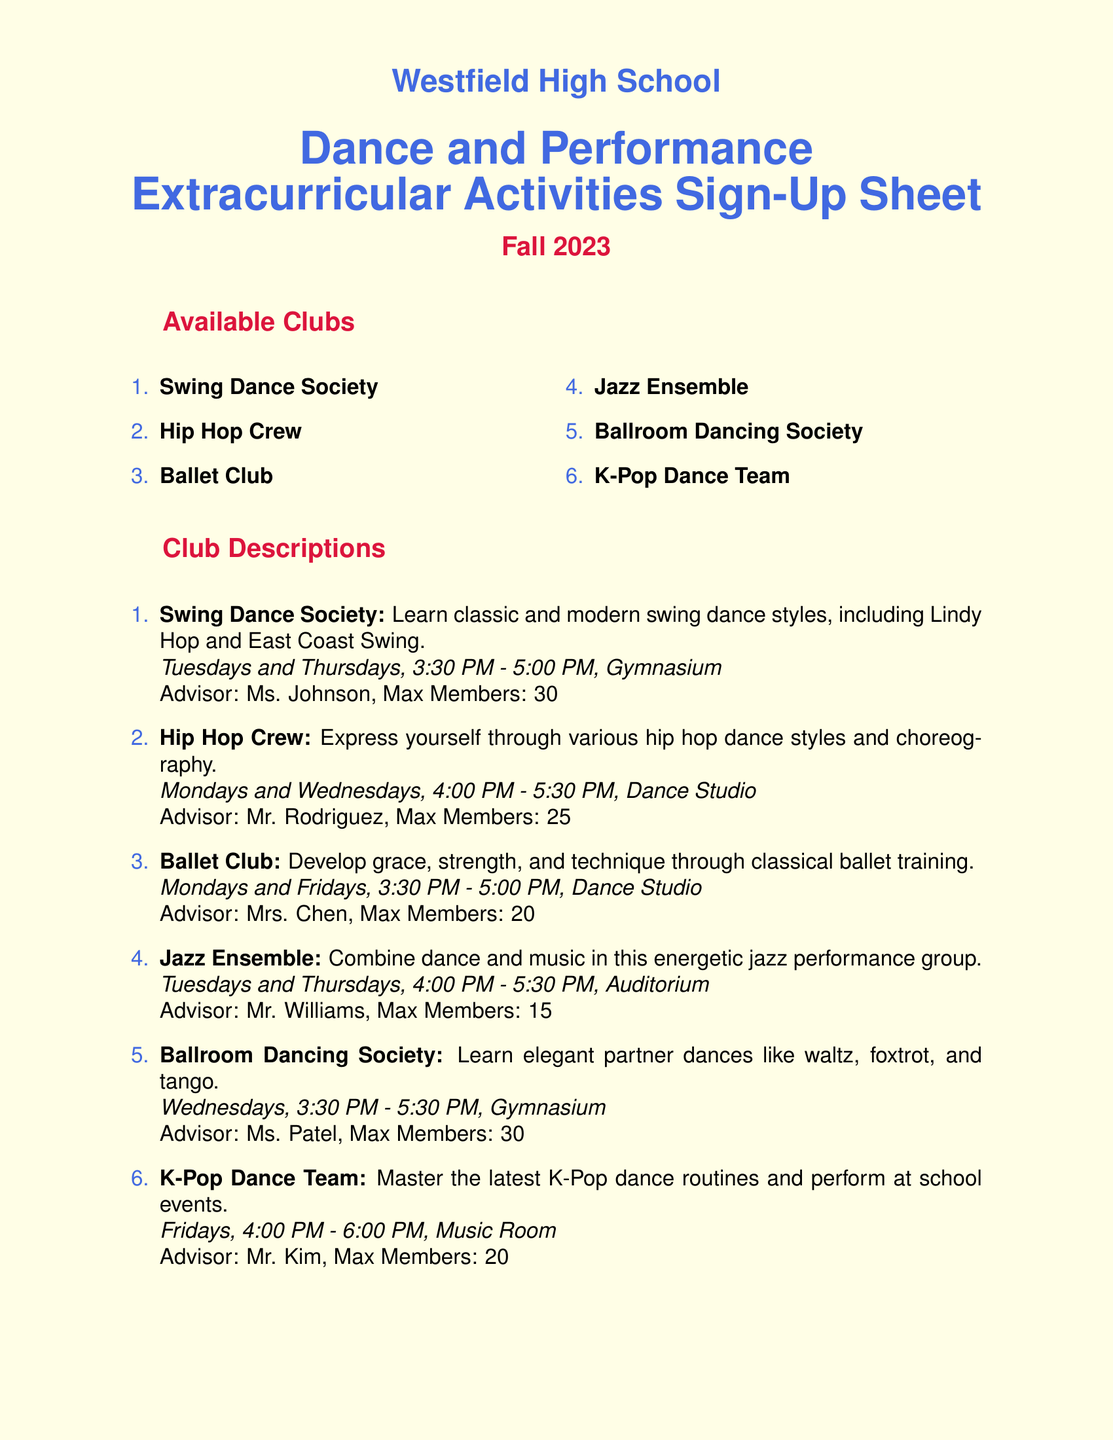What is the name of the school? The school name is provided at the top of the document.
Answer: Westfield High School Who is the advisor for the Swing Dance Society? Each club has an advisor listed in the description.
Answer: Ms. Johnson What day do the Hip Hop Crew meetings occur? The meeting days for each club are specified in the descriptions.
Answer: Mondays and Wednesdays How many members can the Jazz Ensemble accommodate? Each club has a maximum member count stated in the details.
Answer: 15 What is the meeting time for Ballet Club? The meeting time is given for each club in the document.
Answer: Mondays and Fridays, 3:30 PM - 5:00 PM Which club has the most available spots for members? To find this, you compare the maximum members for each club.
Answer: Swing Dance Society and Ballroom Dancing Society What must students agree to by signing up? The sign-up sheet includes a disclaimer outlining an agreement.
Answer: Commit to regular attendance and participation What is the last section listed in the document? The order of sections is indicated in the document layout.
Answer: Signatures What is the last dance club listed? The clubs are listed sequentially in the document.
Answer: K-Pop Dance Team 